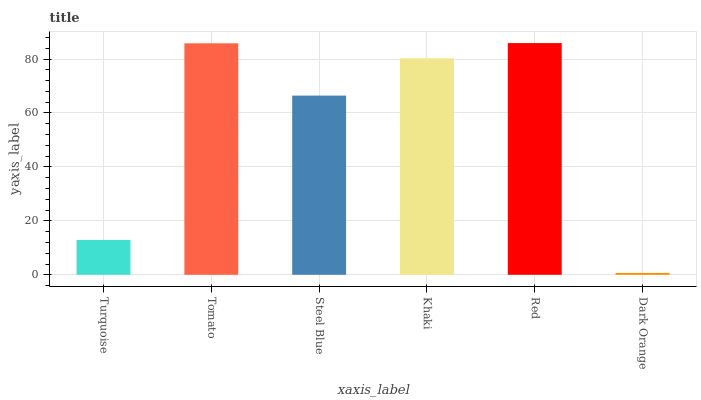Is Tomato the minimum?
Answer yes or no. No. Is Tomato the maximum?
Answer yes or no. No. Is Tomato greater than Turquoise?
Answer yes or no. Yes. Is Turquoise less than Tomato?
Answer yes or no. Yes. Is Turquoise greater than Tomato?
Answer yes or no. No. Is Tomato less than Turquoise?
Answer yes or no. No. Is Khaki the high median?
Answer yes or no. Yes. Is Steel Blue the low median?
Answer yes or no. Yes. Is Red the high median?
Answer yes or no. No. Is Dark Orange the low median?
Answer yes or no. No. 